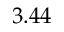<formula> <loc_0><loc_0><loc_500><loc_500>3 . 4 4</formula> 